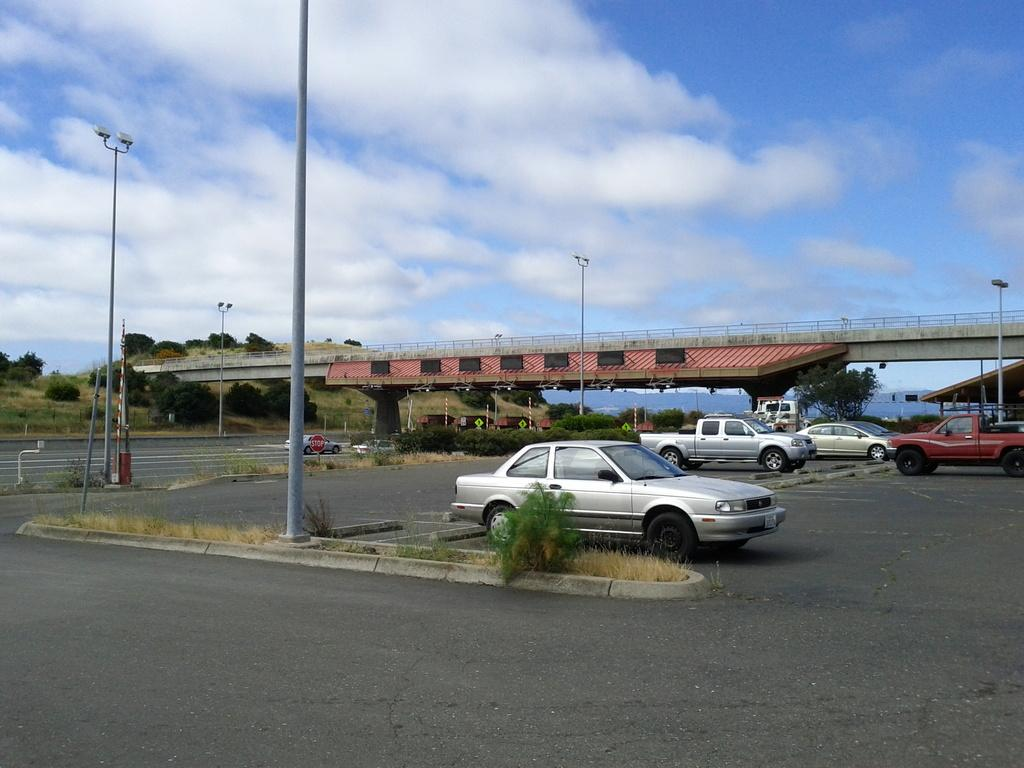What can be seen in the sky in the image? The sky with clouds is visible in the image. What type of structures are present along the road? There are street poles and a foot over bridge in the image. What is used for illumination at night? Street lights are present in the image. What type of surface is used for walking and driving? There is a road and a pavement visible in the image. What type of vegetation is present in the image? Grass, plants, and trees are visible in the image. What type of transportation is present in the image? Vehicles are in the image. What type of information might be conveyed by the sign board? A sign board is present in the image, which might convey information such as directions or advertisements. What type of bean is being used to make the drink in the image? There is no bean or drink present in the image. Who gave their approval for the construction of the foot over bridge in the image? The image does not provide information about who gave approval for the construction of the foot over bridge. 